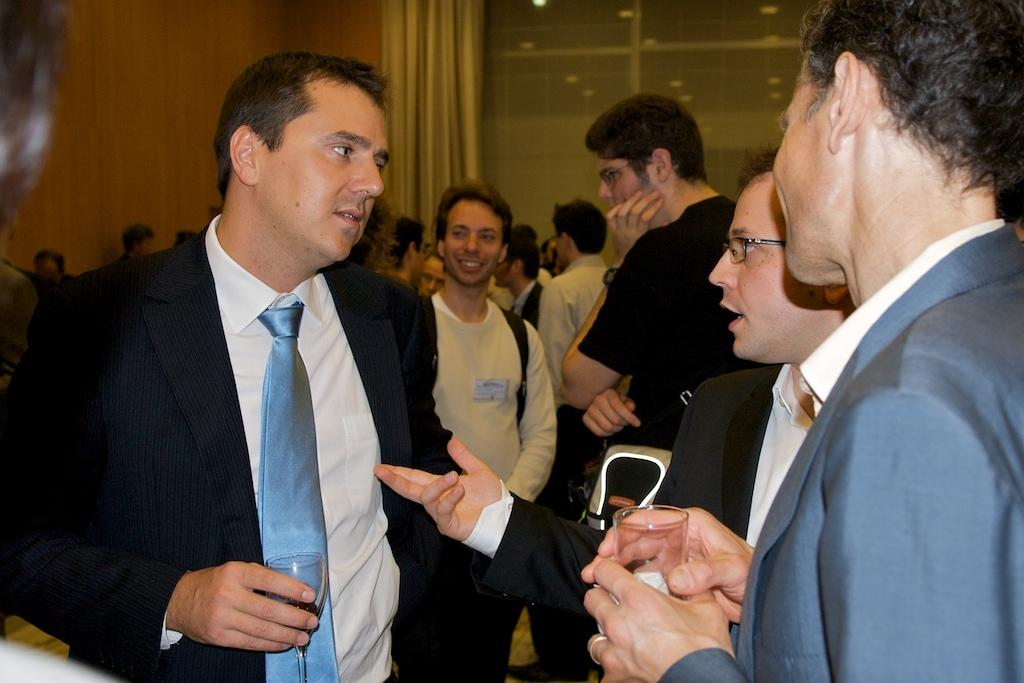How many people are in the image? There is a group of people in the image. What is one person in the group doing? One person is talking. What are two people in the group holding? Two people are holding glasses. What can be seen in the background of the image? There is a wall, curtains, and a glass object in the background of the image. What type of fan is visible in the image? There is no fan present in the image. Can you describe the alley in the background of the image? There is no alley present in the image; it features a wall, curtains, and a glass object in the background. 